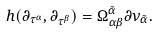Convert formula to latex. <formula><loc_0><loc_0><loc_500><loc_500>h ( \partial _ { \tau ^ { \alpha } } , \partial _ { \tau ^ { \beta } } ) = \Omega _ { \alpha \beta } ^ { { \tilde { \alpha } } } \partial \nu _ { \tilde { \alpha } } .</formula> 